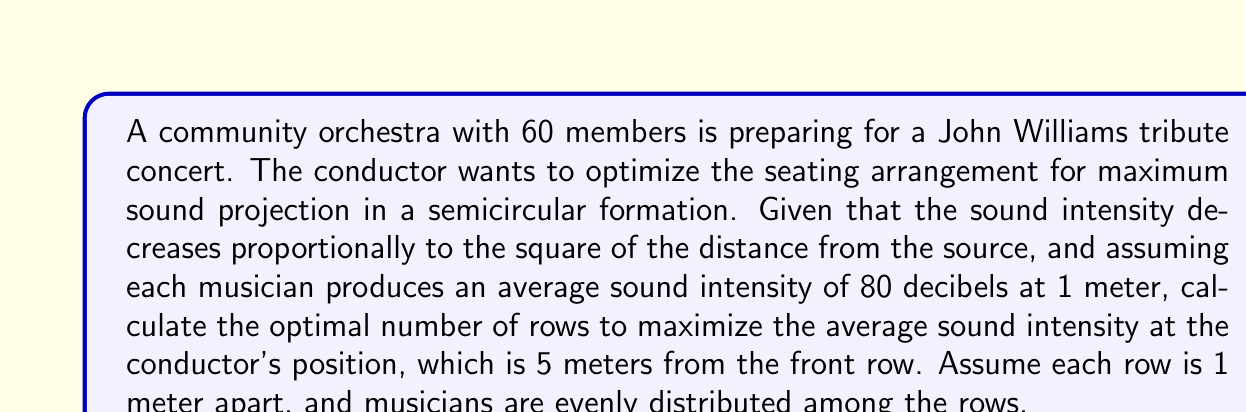Can you solve this math problem? Let's approach this step-by-step:

1) First, we need to establish a relationship between the number of rows and the number of musicians per row. If we have $n$ rows, then the number of musicians per row will be $\frac{60}{n}$.

2) The sound intensity at a distance $r$ from a point source is given by:

   $$I = \frac{I_0}{r^2}$$

   where $I_0$ is the intensity at 1 meter.

3) For each row, we need to calculate its distance from the conductor. For the $i$-th row (starting from 0), the distance will be:

   $$r_i = 5 + i$$

4) The total sound intensity at the conductor's position will be the sum of contributions from all rows:

   $$I_{total} = \sum_{i=0}^{n-1} \frac{60}{n} \cdot \frac{80}{(5+i)^2}$$

5) We want to maximize the average intensity, which is:

   $$I_{avg} = \frac{1}{n} \sum_{i=0}^{n-1} \frac{4800}{n(5+i)^2}$$

6) To find the optimal number of rows, we need to calculate this for different values of $n$ and find the maximum. We can do this programmatically or by calculating for reasonable values (e.g., 1 to 10 rows).

7) Calculating for n = 1 to 10:

   n = 1: 192.00 dB
   n = 2: 156.80 dB
   n = 3: 140.44 dB
   n = 4: 130.56 dB
   n = 5: 123.65 dB
   n = 6: 118.40 dB
   n = 7: 114.29 dB
   n = 8: 110.99 dB
   n = 9: 108.31 dB
   n = 10: 106.11 dB

8) The maximum average intensity is achieved when n = 1, which means having all musicians in a single row.
Answer: 1 row 